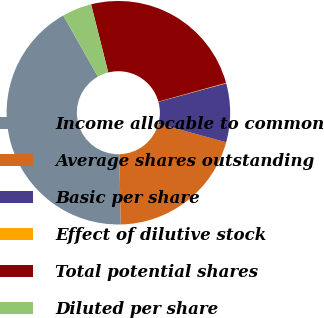Convert chart to OTSL. <chart><loc_0><loc_0><loc_500><loc_500><pie_chart><fcel>Income allocable to common<fcel>Average shares outstanding<fcel>Basic per share<fcel>Effect of dilutive stock<fcel>Total potential shares<fcel>Diluted per share<nl><fcel>42.14%<fcel>20.4%<fcel>8.49%<fcel>0.08%<fcel>24.61%<fcel>4.28%<nl></chart> 